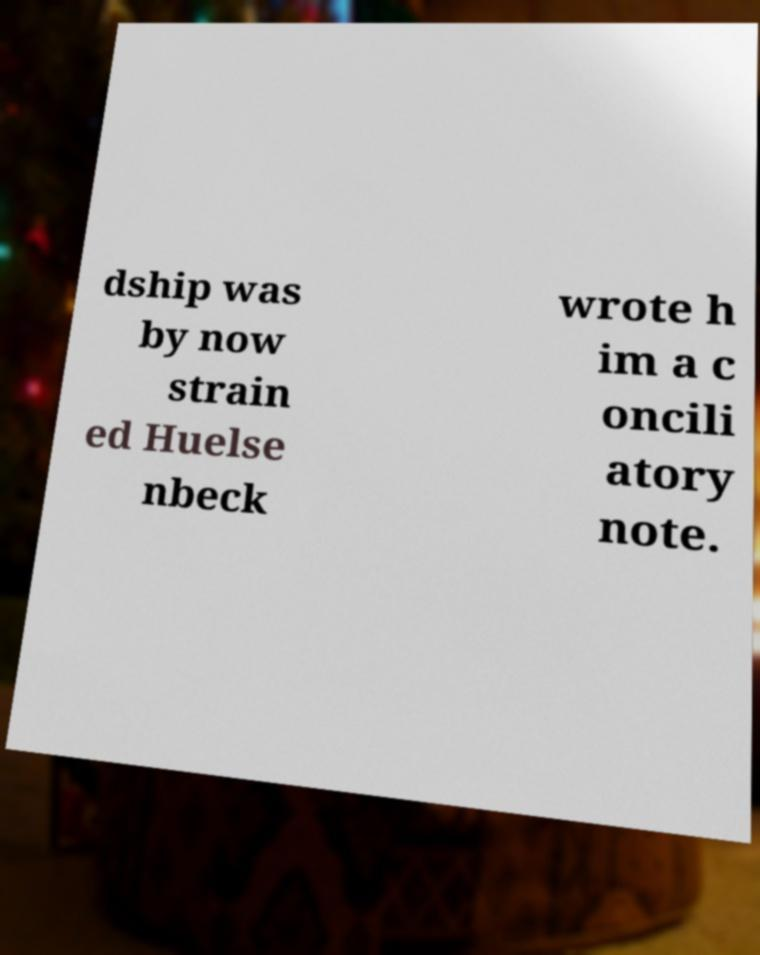There's text embedded in this image that I need extracted. Can you transcribe it verbatim? dship was by now strain ed Huelse nbeck wrote h im a c oncili atory note. 